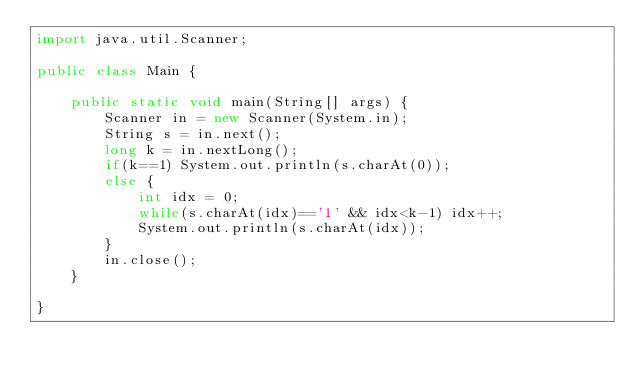<code> <loc_0><loc_0><loc_500><loc_500><_Java_>import java.util.Scanner;

public class Main {

	public static void main(String[] args) {
		Scanner in = new Scanner(System.in);
		String s = in.next();
		long k = in.nextLong();
		if(k==1) System.out.println(s.charAt(0));
		else {
			int idx = 0;
			while(s.charAt(idx)=='1' && idx<k-1) idx++;
			System.out.println(s.charAt(idx));
		}
		in.close();
	}

}</code> 